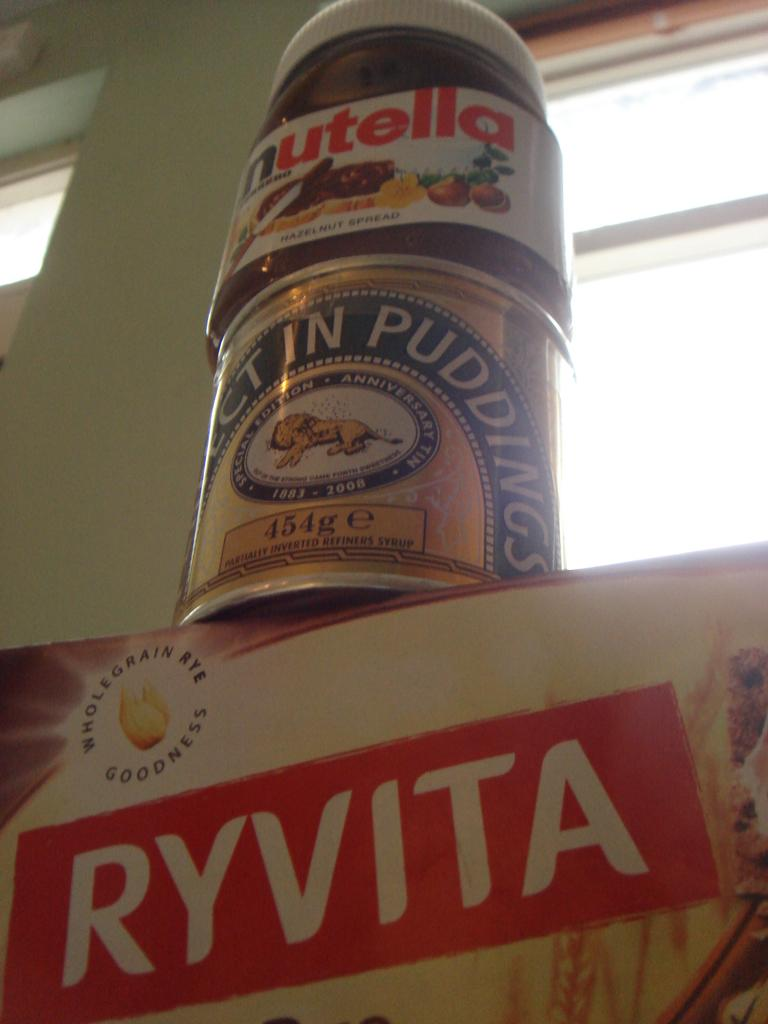<image>
Offer a succinct explanation of the picture presented. A jar of nutella atop a can of pudding over a box of ryvita crackers. 